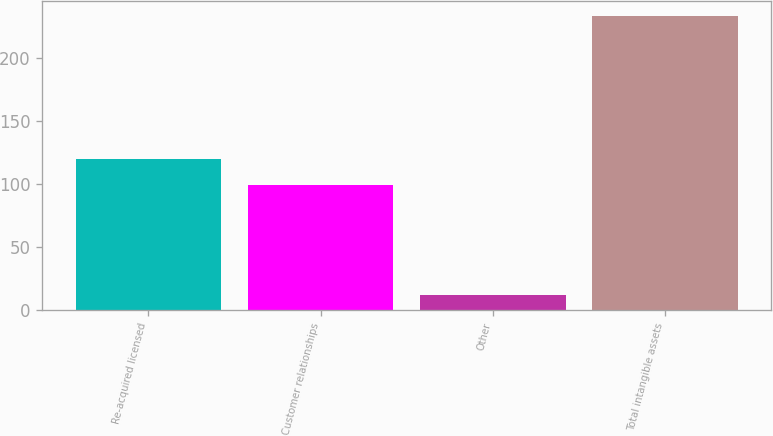Convert chart to OTSL. <chart><loc_0><loc_0><loc_500><loc_500><bar_chart><fcel>Re-acquired licensed<fcel>Customer relationships<fcel>Other<fcel>Total intangible assets<nl><fcel>119.94<fcel>99.2<fcel>12.4<fcel>233.24<nl></chart> 